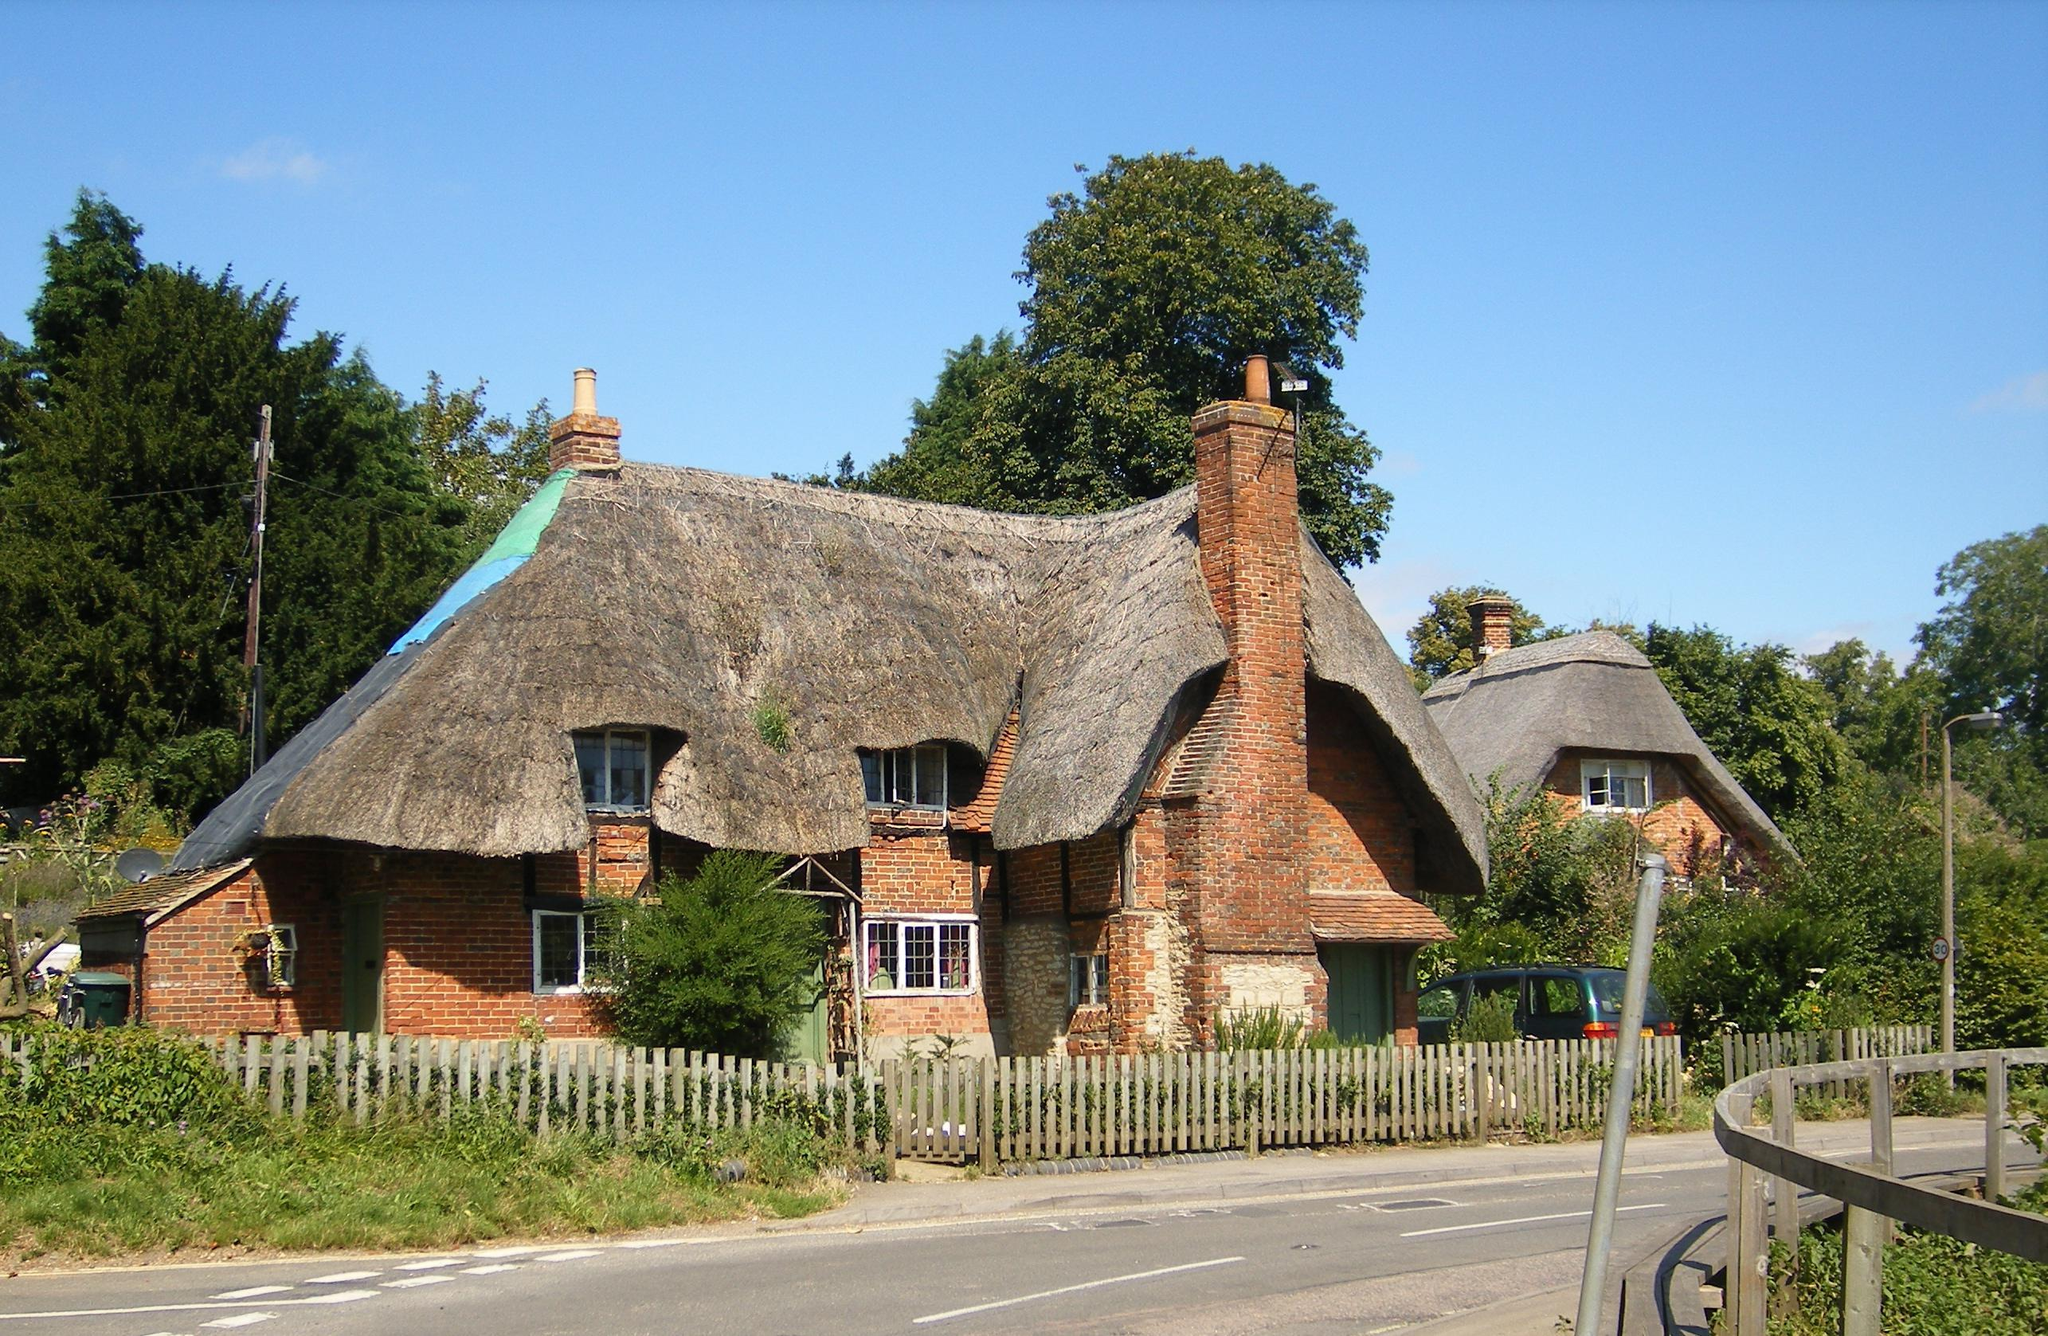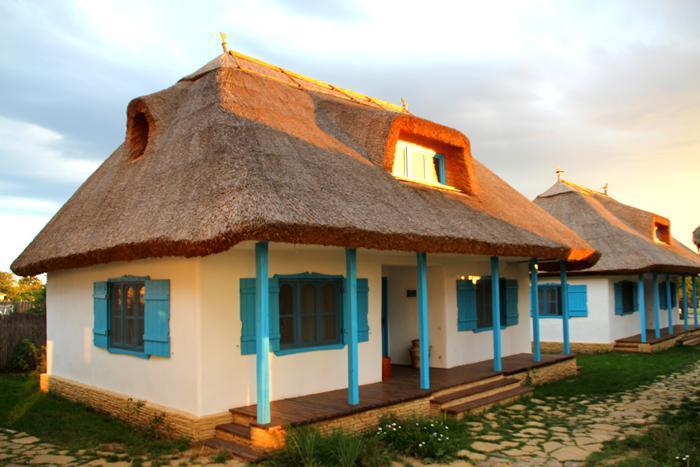The first image is the image on the left, the second image is the image on the right. Assess this claim about the two images: "One roof is partly supported by posts.". Correct or not? Answer yes or no. Yes. The first image is the image on the left, the second image is the image on the right. For the images displayed, is the sentence "The house on the left is behind a fence." factually correct? Answer yes or no. Yes. 